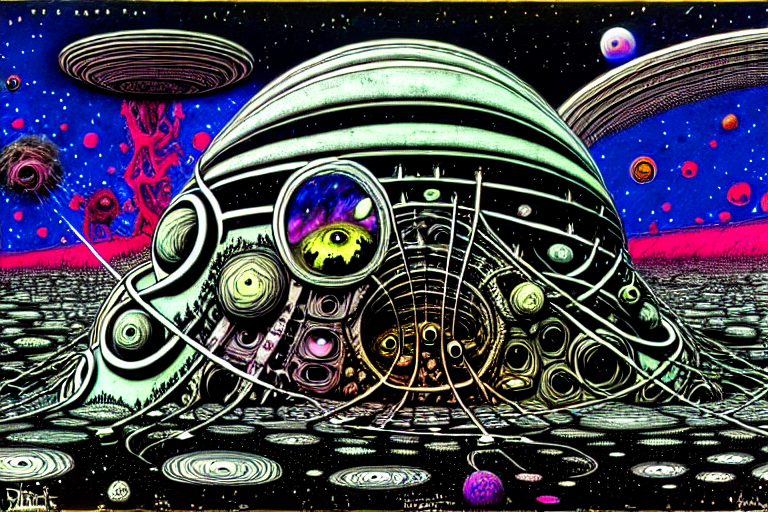Is the overall clarity of the image excellent? Yes, the image presents with excellent clarity, displaying sharp details and vibrant colors that contribute to its overall visual appeal and quality. 